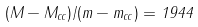Convert formula to latex. <formula><loc_0><loc_0><loc_500><loc_500>( M - M _ { c c } ) / ( m - m _ { c c } ) = 1 9 4 4</formula> 